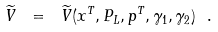Convert formula to latex. <formula><loc_0><loc_0><loc_500><loc_500>\widetilde { V } \ = \ \widetilde { V } ( x ^ { T } , P _ { L } , p ^ { T } , \gamma _ { 1 } , \gamma _ { 2 } ) \ .</formula> 